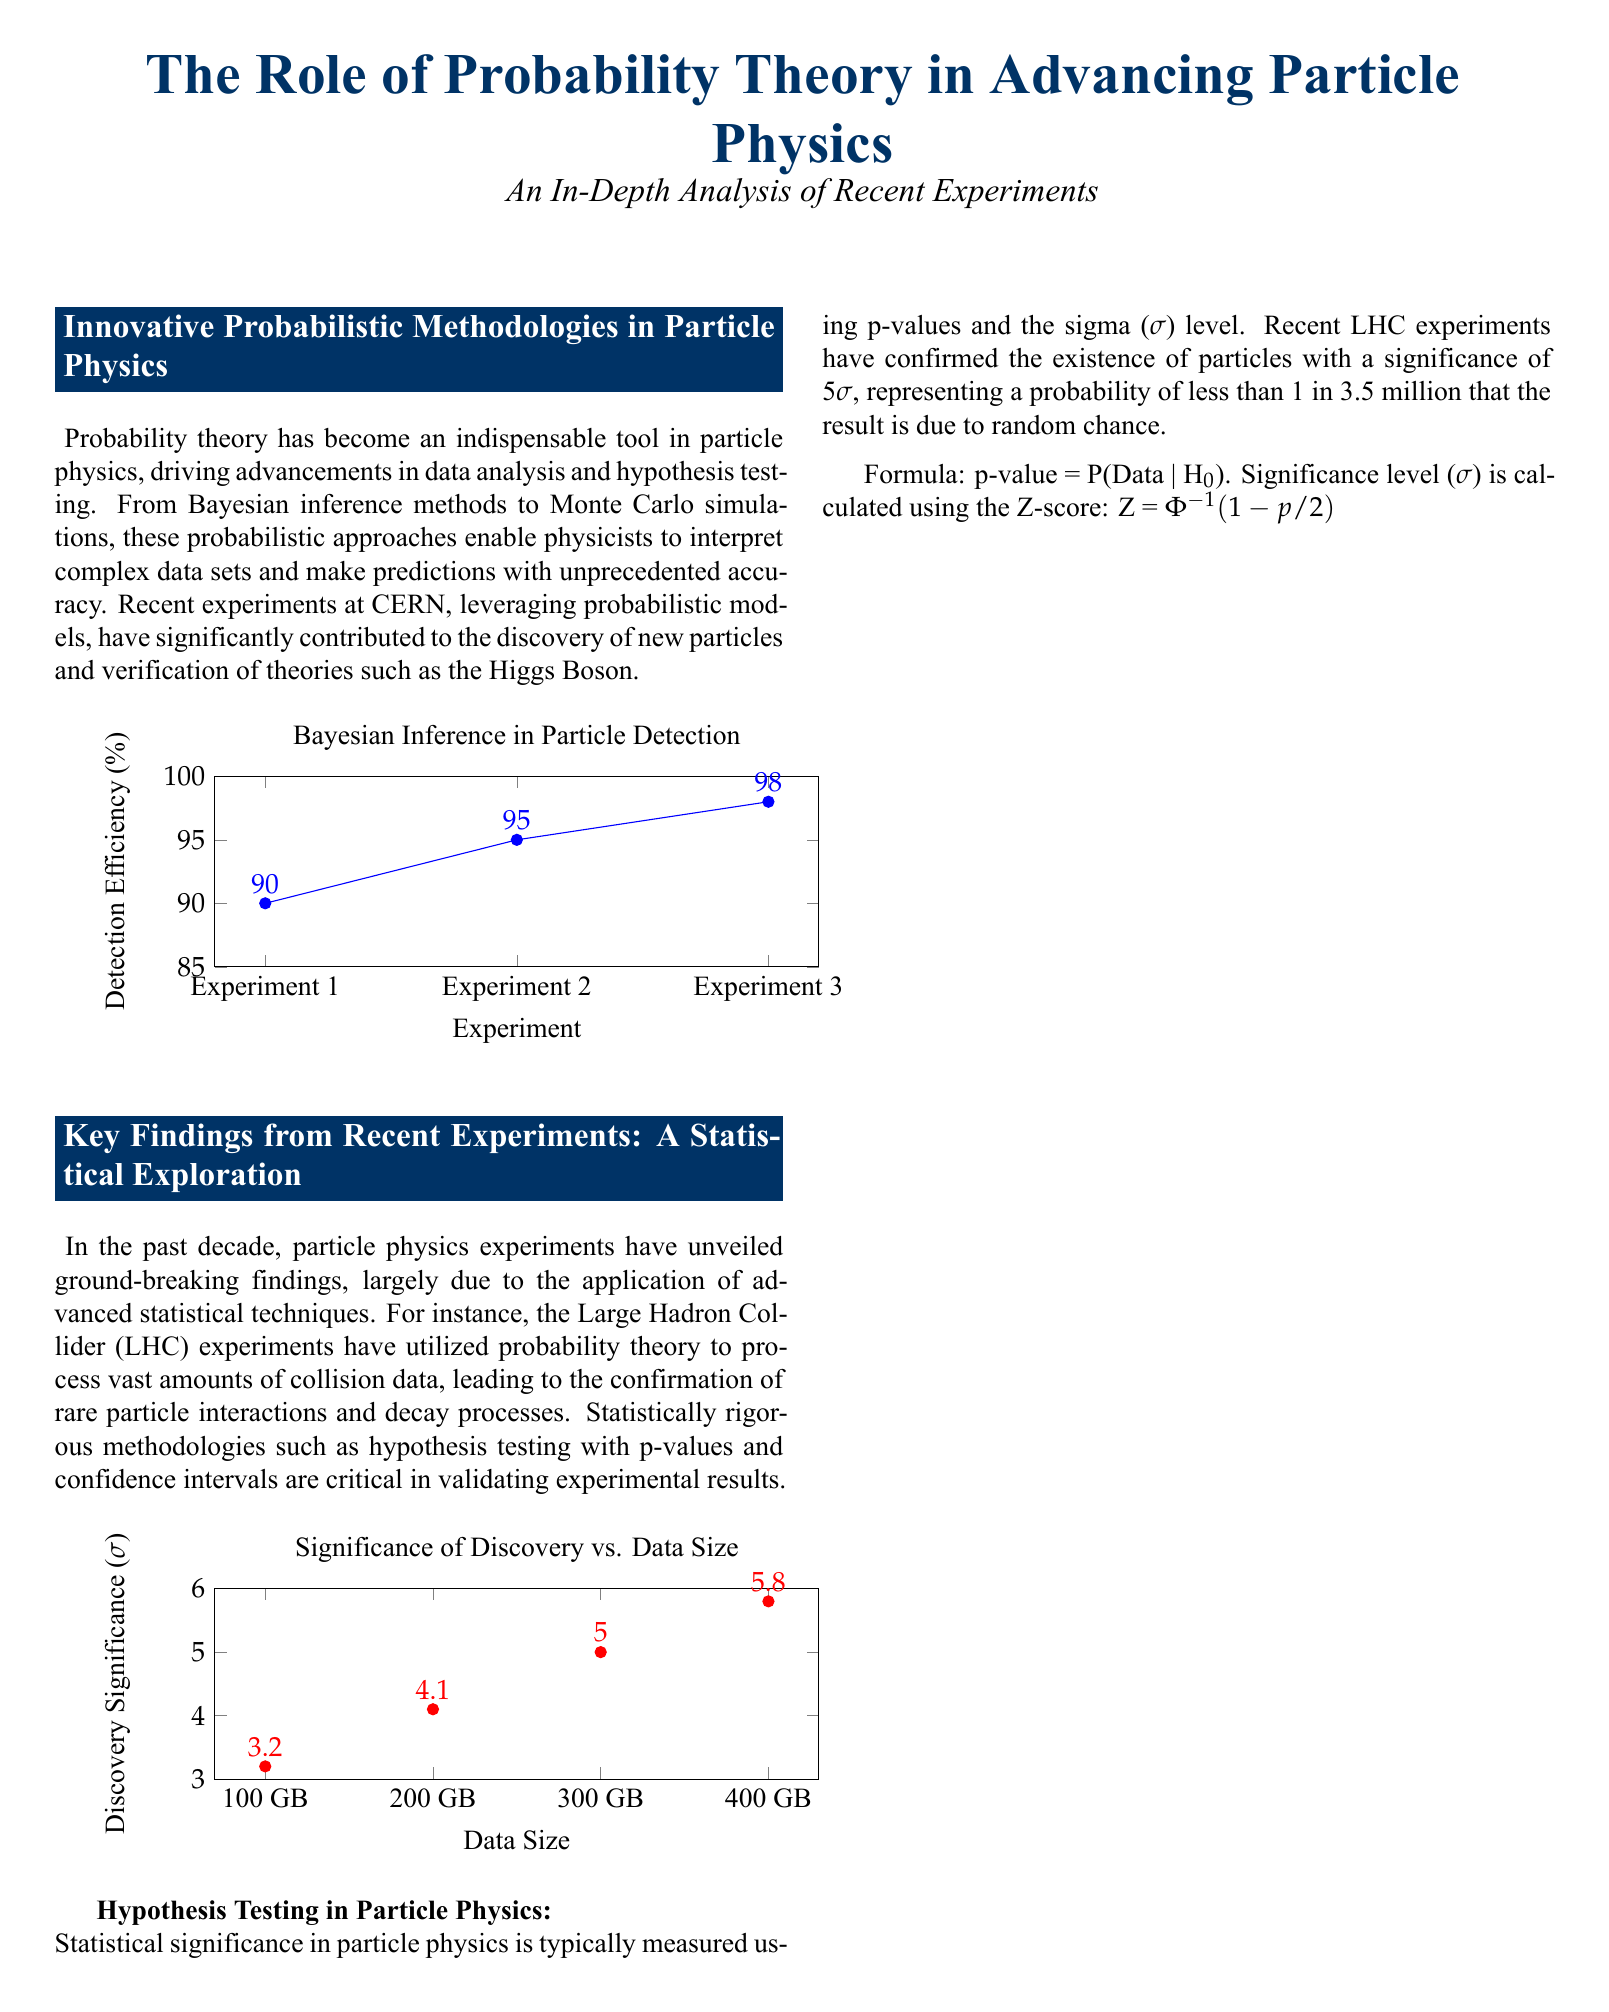What is the title of the document? The title is prominently displayed in the document, summarizing its main theme.
Answer: The Role of Probability Theory in Advancing Particle Physics What color represents the heading in the document? The heading color is specifically defined in the document as a certain RGB value.
Answer: RGB(0,51,102) What is the detection efficiency for Experiment 3? The efficiency is shown on the chart illustrating Bayesian Inference in Particle Detection.
Answer: 98 What is the significance level reported for the recent LHC experiments? This information is mentioned in the section discussing hypothesis testing.
Answer: 5σ What is the minimum data size mentioned in the Discovery Significance chart? The chart specifies the different sizes related to discovery significance.
Answer: 100 GB What is the primary probabilistic methodology mentioned in particle physics? This term frequently appears in discussions about data interpretation and modeling.
Answer: Bayesian inference What is the range of detection efficiency displayed in the document? This is the difference between the lowest and highest values shown in the chart.
Answer: 8% What does the symbol σ represent in particle physics? The document provides a specific context regarding the use of this symbol in experimental results.
Answer: Significance How many times are the words "probability theory" mentioned in the document? A specific section of the document focuses on its role and mentions it several times.
Answer: 4 